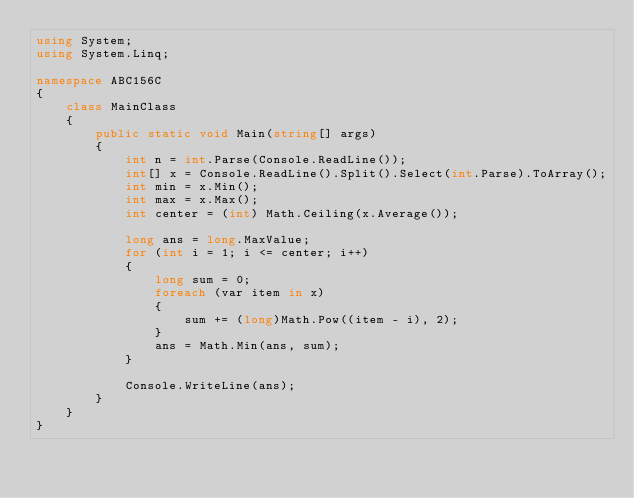Convert code to text. <code><loc_0><loc_0><loc_500><loc_500><_C#_>using System;
using System.Linq;

namespace ABC156C
{
    class MainClass
    {
        public static void Main(string[] args)
        {
            int n = int.Parse(Console.ReadLine());
            int[] x = Console.ReadLine().Split().Select(int.Parse).ToArray();
            int min = x.Min();
            int max = x.Max();
            int center = (int) Math.Ceiling(x.Average());

            long ans = long.MaxValue;
            for (int i = 1; i <= center; i++)
            {
                long sum = 0;
                foreach (var item in x)
                {
                    sum += (long)Math.Pow((item - i), 2);
                }
                ans = Math.Min(ans, sum);
            }

            Console.WriteLine(ans);
        }
    }
}
</code> 